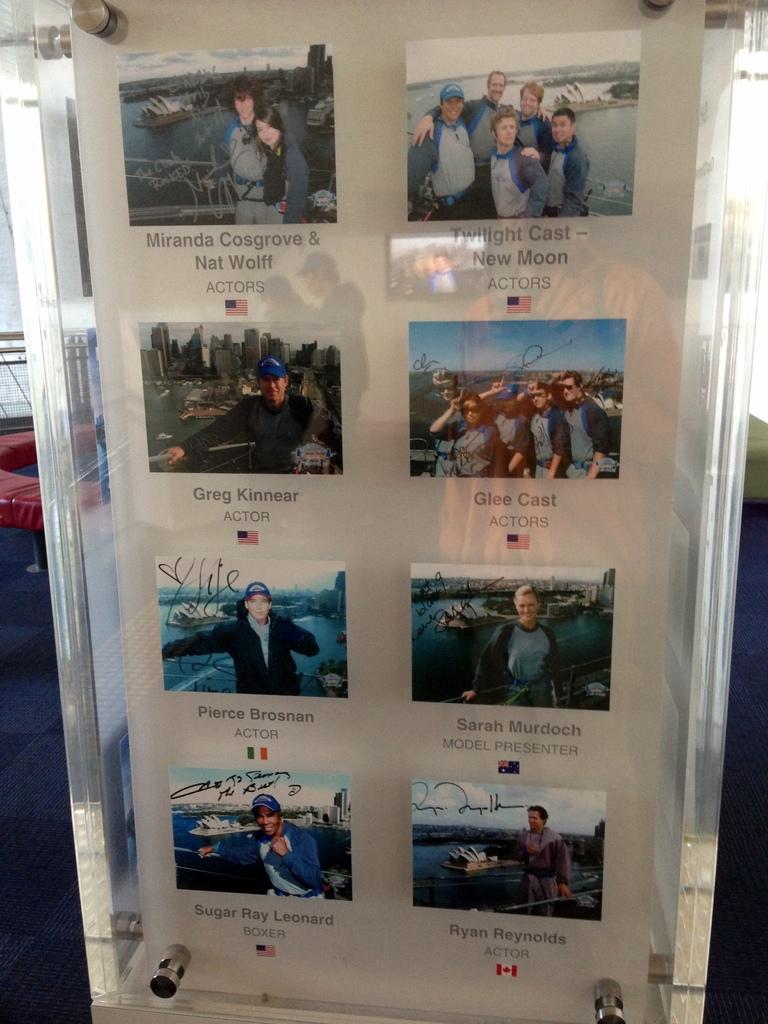What is one of the names on this board?
Make the answer very short. Greg kinnear. It is glee cast?
Offer a terse response. Yes. 